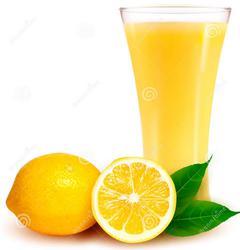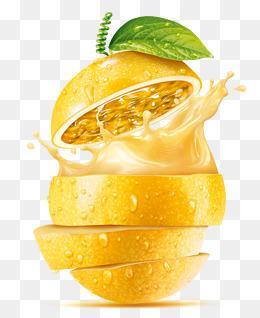The first image is the image on the left, the second image is the image on the right. Considering the images on both sides, is "One image includes a whole and half lemon and two green leaves by a yellow beverage in a glass with a flared top." valid? Answer yes or no. Yes. The first image is the image on the left, the second image is the image on the right. Given the left and right images, does the statement "There is a glass of lemonade with lemons next to it, there is 1/2 of a lemon and the lemon greens from the fruit are visible, the glass is smaller around on the bottom and tapers wider at the top" hold true? Answer yes or no. Yes. 